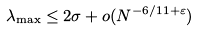<formula> <loc_0><loc_0><loc_500><loc_500>\lambda _ { \max } \leq 2 \sigma + o ( N ^ { - 6 / 1 1 + \varepsilon } )</formula> 